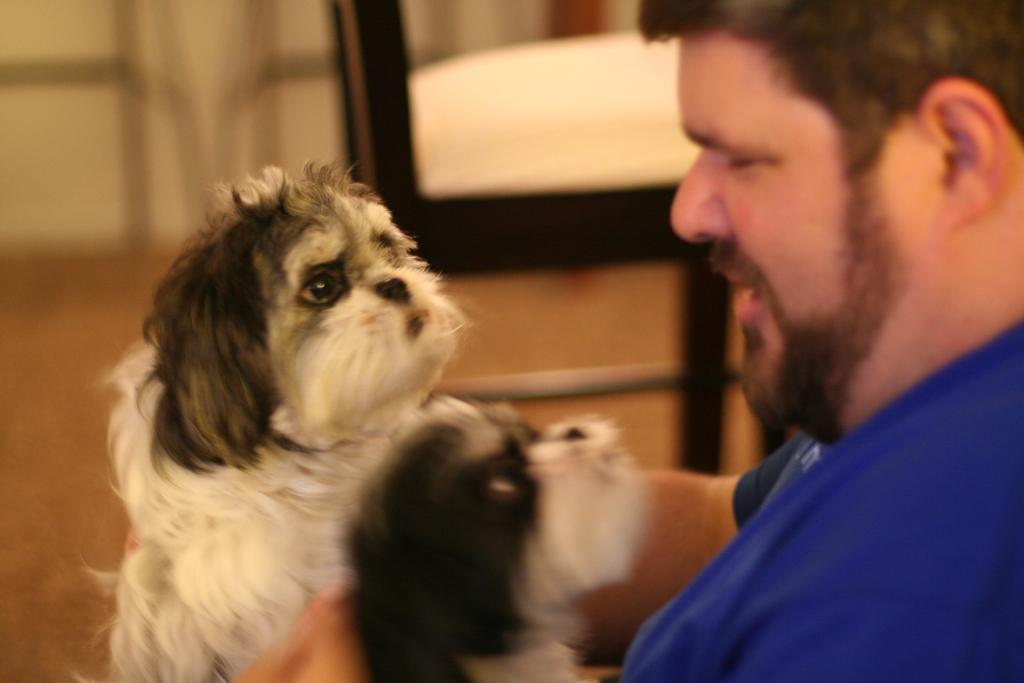Who is present in the image? There is a man in the image. What is the man holding in the image? The man is holding two dogs. What can be seen in the background of the image? There is a chair and a wall in the background of the image. What type of patch is the man wearing on his shirt in the image? There is no patch visible on the man's shirt in the image. 